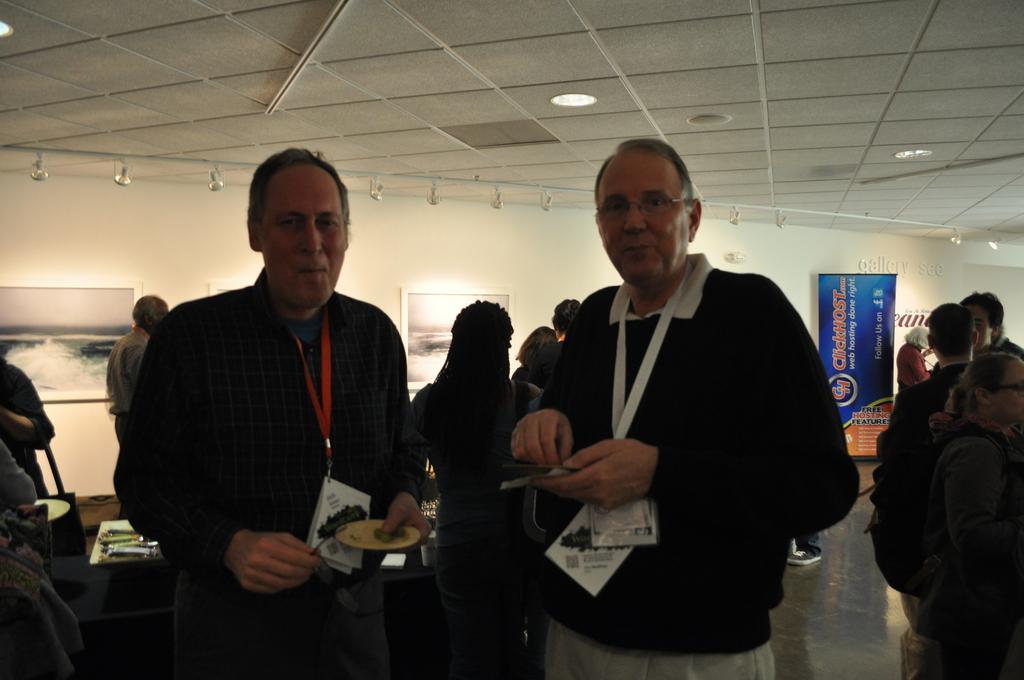In one or two sentences, can you explain what this image depicts? In this picture we can see two men standing and smiling and at the back of them we can see a group of people, banner, frames on the wall. 